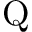Convert formula to latex. <formula><loc_0><loc_0><loc_500><loc_500>Q</formula> 